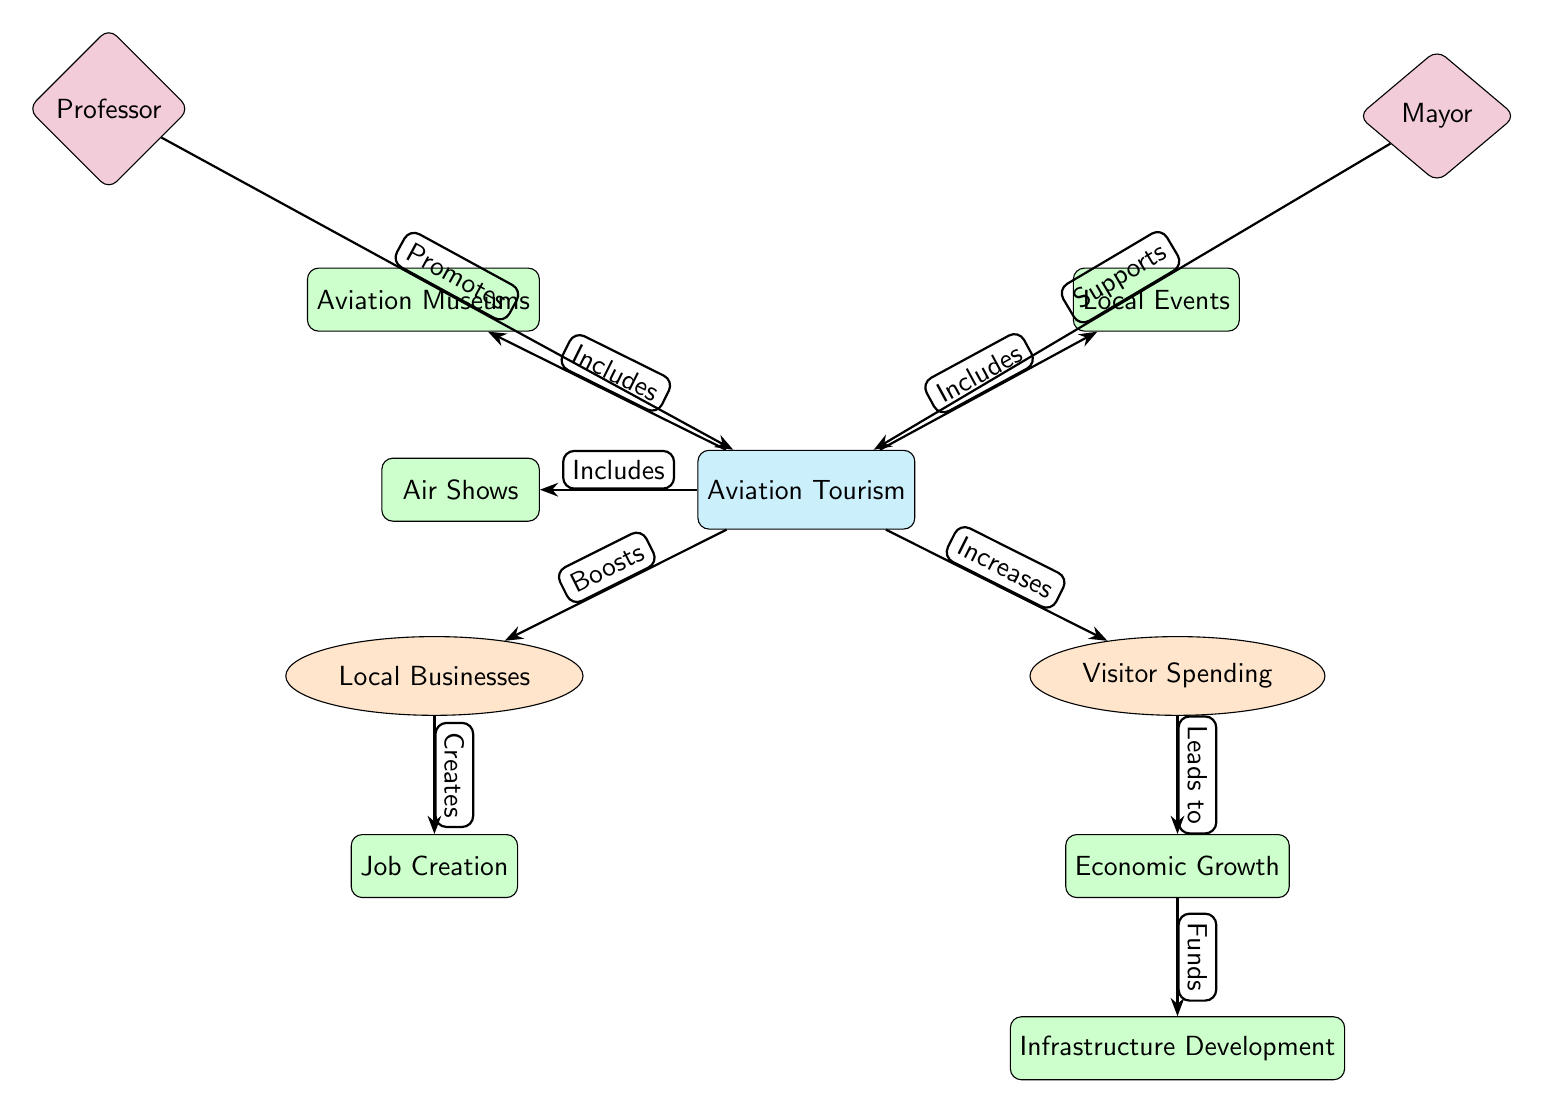What is the main topic of the diagram? The main node is labeled "Aviation Tourism," indicating that it is the central theme of the diagram.
Answer: Aviation Tourism How many secondary nodes are connected to "Aviation Tourism"? There are two secondary nodes connected to "Aviation Tourism": "Local Businesses" and "Visitor Spending."
Answer: 2 What does "Local Businesses" lead to? The edge from "Local Businesses" points to "Job Creation," indicating that local businesses contribute to job creation.
Answer: Job Creation What are the three aspects included under "Aviation Tourism"? The three aspects included as tertiary nodes are "Air Shows," "Aviation Museums," and "Local Events," showcasing the different elements of aviation tourism.
Answer: Air Shows, Aviation Museums, Local Events Who promotes "Aviation Tourism"? The node labeled "Professor" is connected to "Aviation Tourism" with an edge that indicates the professor's role in promotion.
Answer: Professor What leads to "Economic Growth"? The edge from "Visitor Spending" to "Economic Growth" indicates that visitor spending directly contributes to economic growth.
Answer: Visitor Spending What is the final outcome of "Economic Growth" as per the diagram? The edge from "Economic Growth" leads to "Infrastructure Development," showing that economic growth leads to improvements in infrastructure.
Answer: Infrastructure Development What role does the mayor play in relation to "Aviation Tourism"? The connection shows that the mayor supports aviation tourism, which suggests active involvement in promoting it.
Answer: Supports How does "Visitor Spending" relate to "Local Businesses"? "Visitor Spending" contributes to "Local Businesses," signifying that increased visitor expenditure positively affects local business operations.
Answer: Boosts 